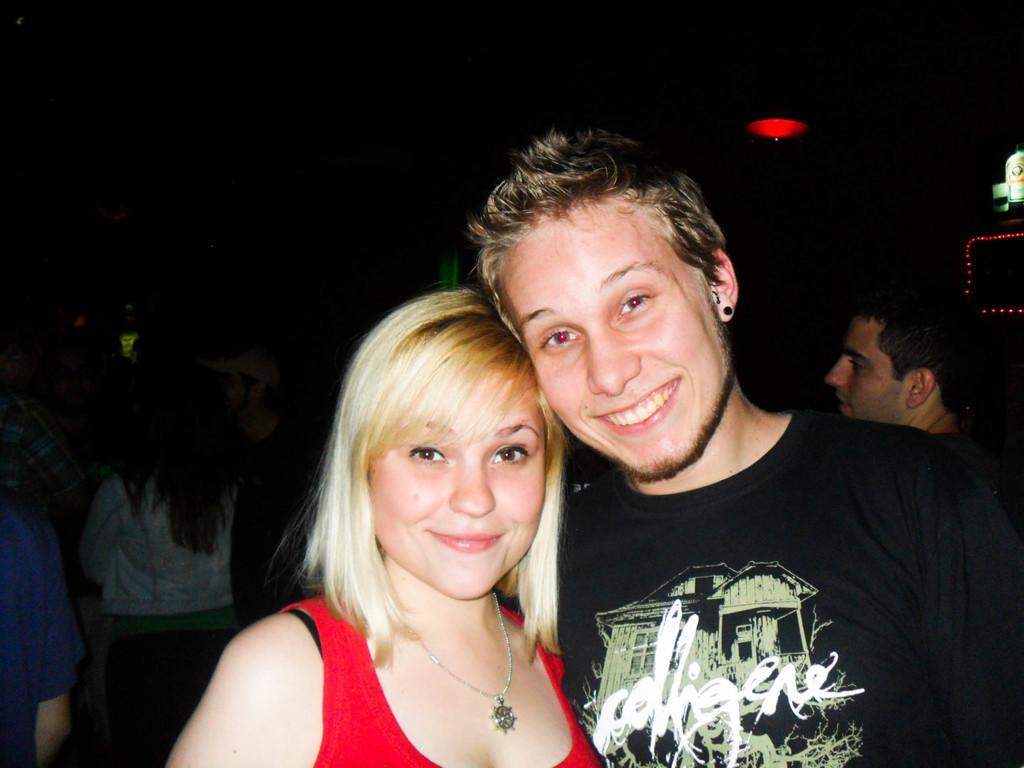Please provide a concise description of this image. In this picture we can see a woman and man standing together and they are smiling. She has a brown hair. And on the left side of the picture some people are standing together. Even in the right side of picture there is a man. And on the background we can see a red colored light. 